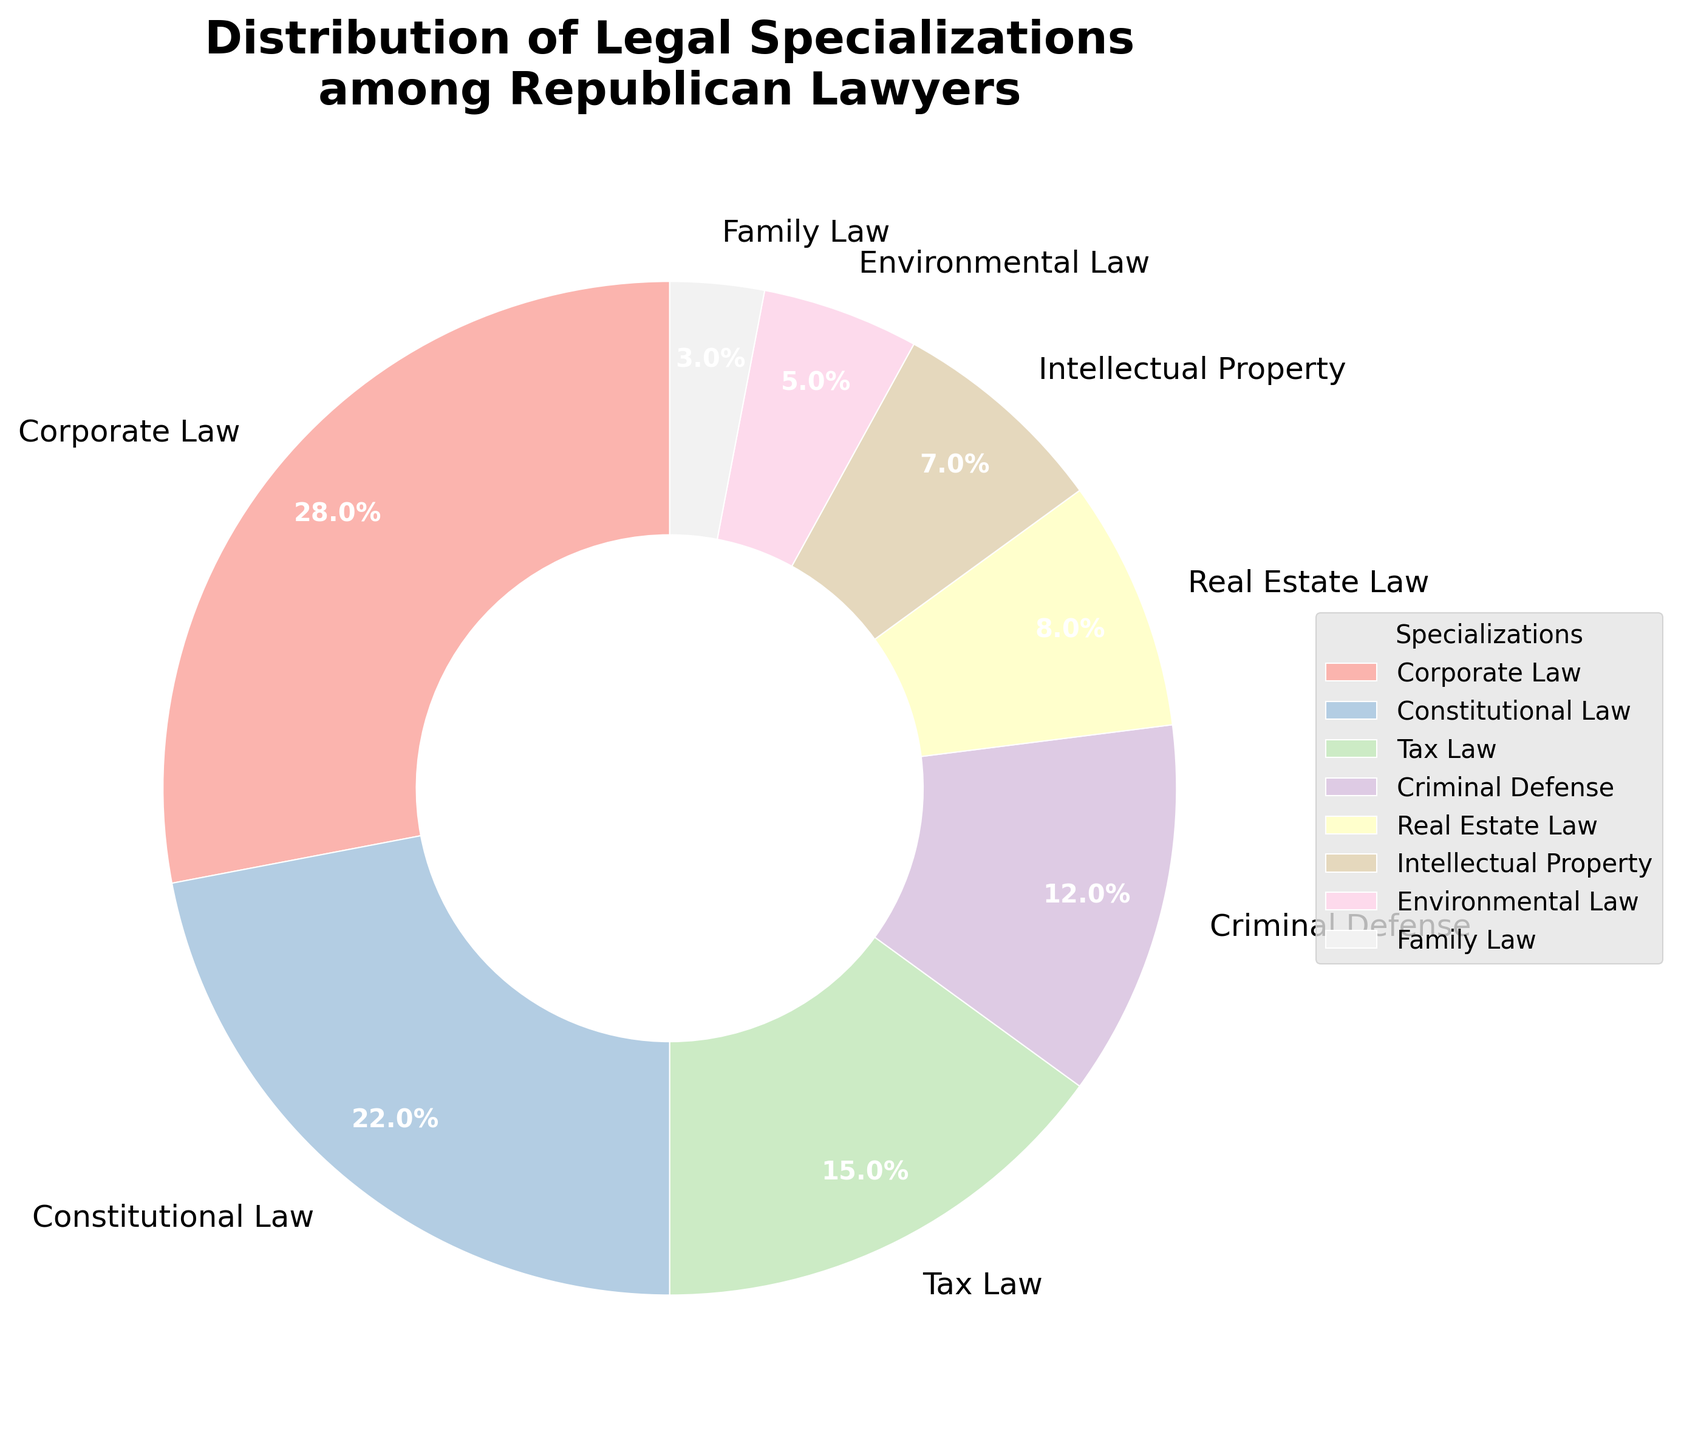What is the title of the pie chart? The title appears at the top of the figure and is in bold, large font.
Answer: Distribution of Legal Specializations among Republican Lawyers Which specialization has the highest percentage? By inspecting the pie chart, you can see that the largest wedge is labeled with a specific specialization.
Answer: Corporate Law What is the combined percentage of lawyers specializing in Corporate Law and Constitutional Law? Add the percentages of Corporate Law and Constitutional Law by summing their individual values from the pie chart.
Answer: 50% Which specialization has a lower percentage, Real Estate Law or Intellectual Property? Compare the wedges' sizes and percentages labeled with Real Estate Law and Intellectual Property.
Answer: Intellectual Property What is the percentage difference between Tax Law and Criminal Defense? Subtract the smaller percentage (Criminal Defense) from the larger percentage (Tax Law).
Answer: 3% How many specializations have a percentage less than 10%? Count all the labeled wedges with percentages smaller than 10% by inspecting the figure.
Answer: 4 Which specialization occupies approximately one-fourth of the pie chart? Identify the wedge that makes up roughly 25% of the pie chart by looking at the percentage labels.
Answer: Corporate Law If you add the percentages of Family Law and Environmental Law, what do you get? Sum the percentages of Family Law and Environmental Law by adding their values together.
Answer: 8% How much more prevalent is Corporate Law than Family Law among Republican lawyers? Subtract the percentage of Family Law from Corporate Law to find the difference.
Answer: 25% Do more lawyers specialize in Real Estate Law compared to Environmental Law? Compare the percentages assigned to Real Estate Law and Environmental Law by inspecting their labeled wedges.
Answer: Yes 